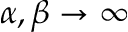<formula> <loc_0><loc_0><loc_500><loc_500>\alpha , \beta \to \infty</formula> 